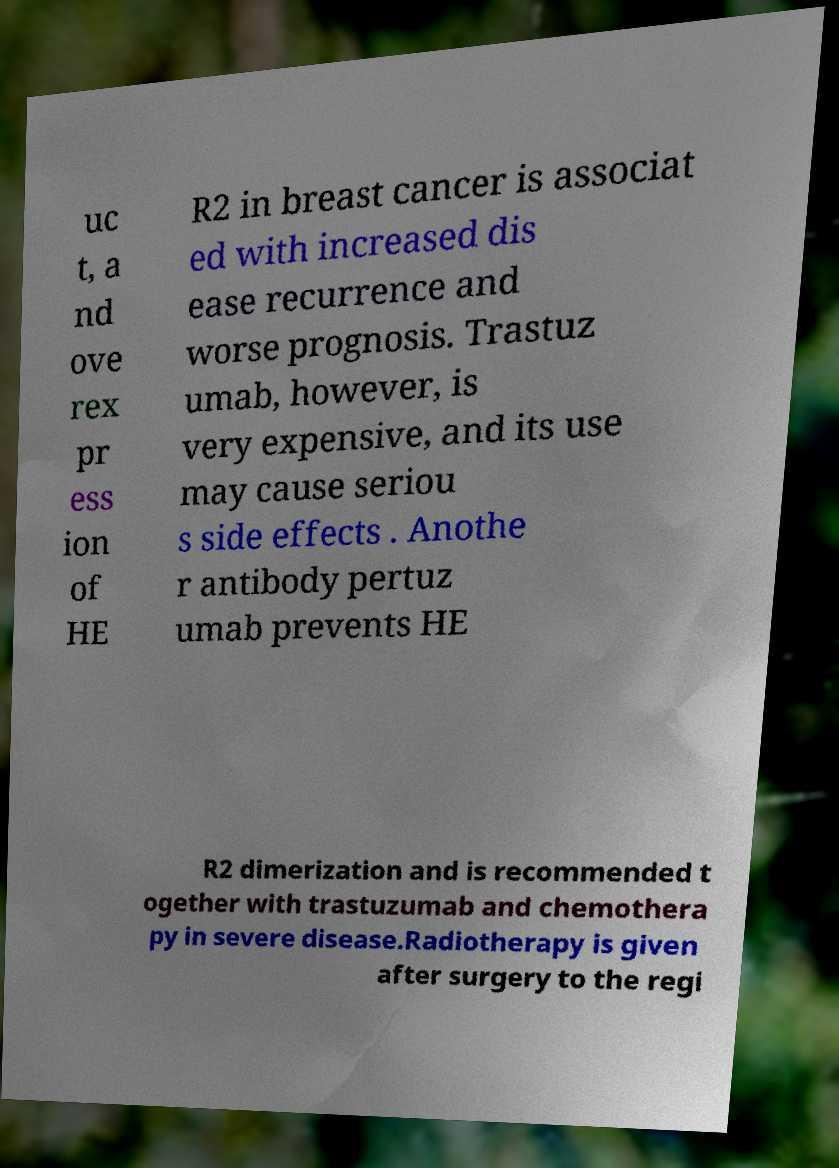What messages or text are displayed in this image? I need them in a readable, typed format. uc t, a nd ove rex pr ess ion of HE R2 in breast cancer is associat ed with increased dis ease recurrence and worse prognosis. Trastuz umab, however, is very expensive, and its use may cause seriou s side effects . Anothe r antibody pertuz umab prevents HE R2 dimerization and is recommended t ogether with trastuzumab and chemothera py in severe disease.Radiotherapy is given after surgery to the regi 